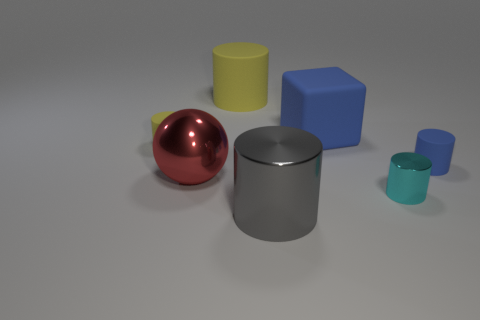Subtract all green balls. How many yellow cylinders are left? 2 Add 3 small yellow rubber cylinders. How many objects exist? 10 Subtract all large yellow rubber cylinders. How many cylinders are left? 4 Subtract all cyan cylinders. How many cylinders are left? 4 Subtract all cubes. How many objects are left? 6 Add 1 red shiny things. How many red shiny things are left? 2 Add 2 small cyan blocks. How many small cyan blocks exist? 2 Subtract 0 yellow spheres. How many objects are left? 7 Subtract all brown cylinders. Subtract all purple cubes. How many cylinders are left? 5 Subtract all gray shiny cylinders. Subtract all red balls. How many objects are left? 5 